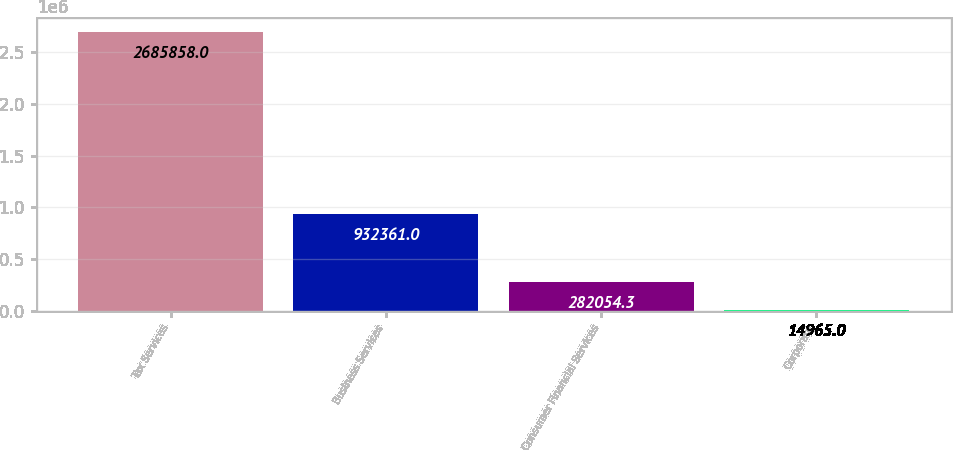Convert chart. <chart><loc_0><loc_0><loc_500><loc_500><bar_chart><fcel>Tax Services<fcel>Business Services<fcel>Consumer Financial Services<fcel>Corporate<nl><fcel>2.68586e+06<fcel>932361<fcel>282054<fcel>14965<nl></chart> 